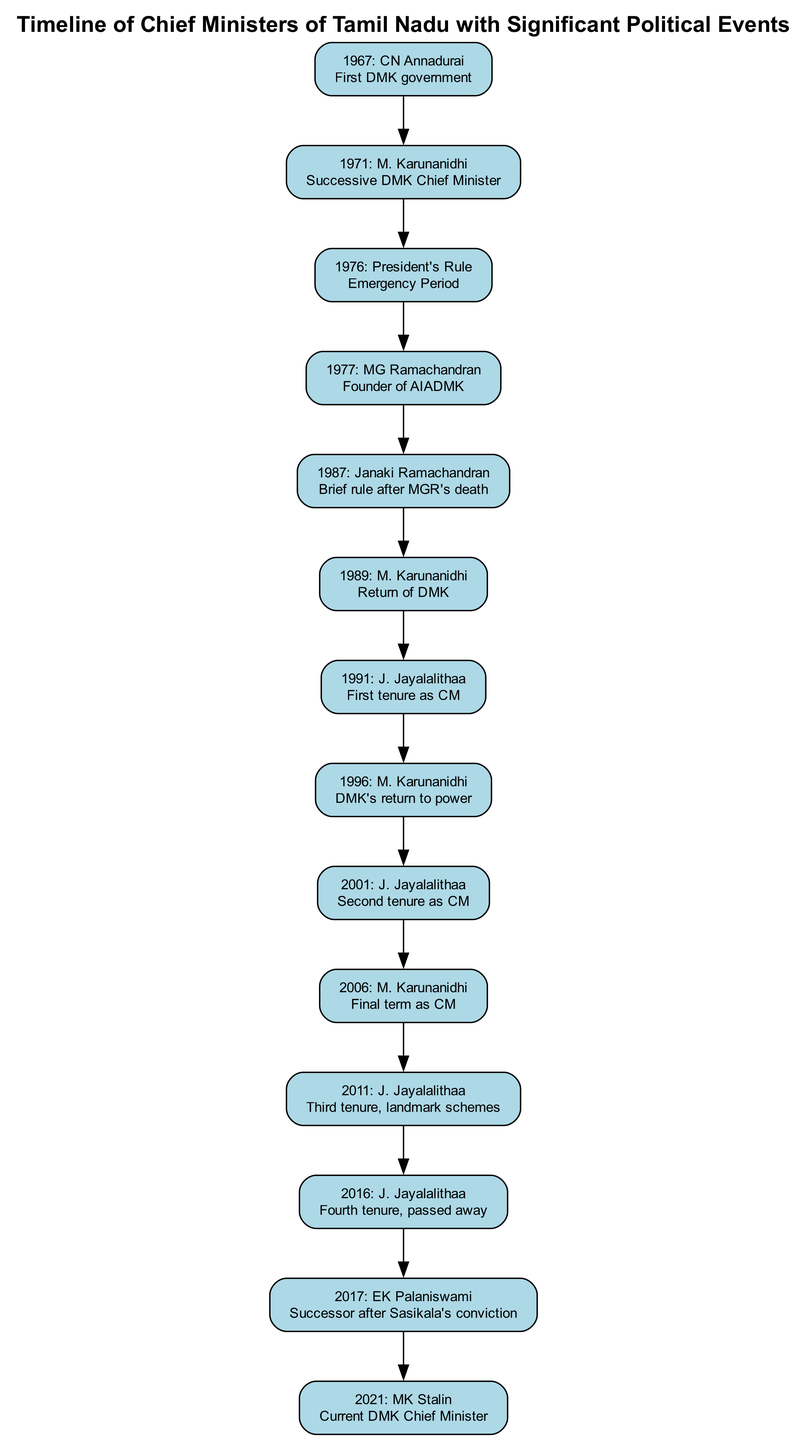What year did CN Annadurai become the Chief Minister of Tamil Nadu? The diagram indicates that CN Annadurai became the Chief Minister in the year 1967.
Answer: 1967 How many Chief Ministers succeeded M. Karunanidhi in the timeline? Looking at the timeline, after M. Karunanidhi (who appears multiple times), the next Chief Minister listed is MG Ramachandran in 1977, followed by Janaki Ramachandran and then J. Jayalalithaa: She becomes the Chief Minister in 1991, indicating three successors.
Answer: 3 What significant political event occurred in 1976? The diagram highlights that in 1976, there was President's Rule in Tamil Nadu, marking a significant interruption in the state's governance.
Answer: President's Rule Which political party is associated with MG Ramachandran? The diagram notes that MG Ramachandran is the founder of the AIADMK, which is the political party he is associated with.
Answer: AIADMK List the years when J. Jayalalithaa served as Chief Minister. The timeline shows that J. Jayalalithaa served as Chief Minister in 1991, 2001, 2011, and 2016, indicating her multiple tenures.
Answer: 1991, 2001, 2011, 2016 What event led to E. K. Palaniswami's assumption of office? According to the diagram, E. K. Palaniswami became Chief Minister in 2017 following Sasikala's conviction, which led to a power transition.
Answer: Sasikala's conviction Which Chief Minister's tenure was marked by landmark schemes? The timeline specifies that J. Jayalalithaa's third tenure as Chief Minister in 2011 was notable for implementing landmark schemes.
Answer: J. Jayalalithaa What is the current Chief Minister's name as per the timeline? The timeline indicates that the current Chief Minister of Tamil Nadu is MK Stalin, who is the latest political figure mentioned in the sequence.
Answer: MK Stalin How many times did M. Karunanidhi serve as Chief Minister? The diagram illustrates that M. Karunanidhi served as Chief Minister in the years 1971, 1989, and 1996, totaling three terms throughout the timeline.
Answer: 3 